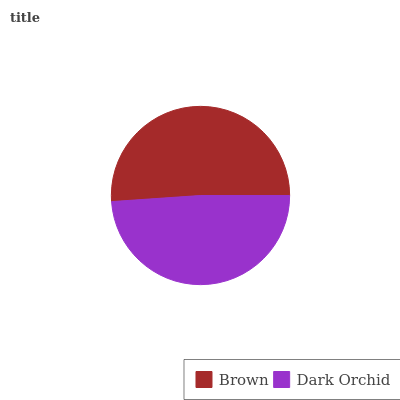Is Dark Orchid the minimum?
Answer yes or no. Yes. Is Brown the maximum?
Answer yes or no. Yes. Is Dark Orchid the maximum?
Answer yes or no. No. Is Brown greater than Dark Orchid?
Answer yes or no. Yes. Is Dark Orchid less than Brown?
Answer yes or no. Yes. Is Dark Orchid greater than Brown?
Answer yes or no. No. Is Brown less than Dark Orchid?
Answer yes or no. No. Is Brown the high median?
Answer yes or no. Yes. Is Dark Orchid the low median?
Answer yes or no. Yes. Is Dark Orchid the high median?
Answer yes or no. No. Is Brown the low median?
Answer yes or no. No. 